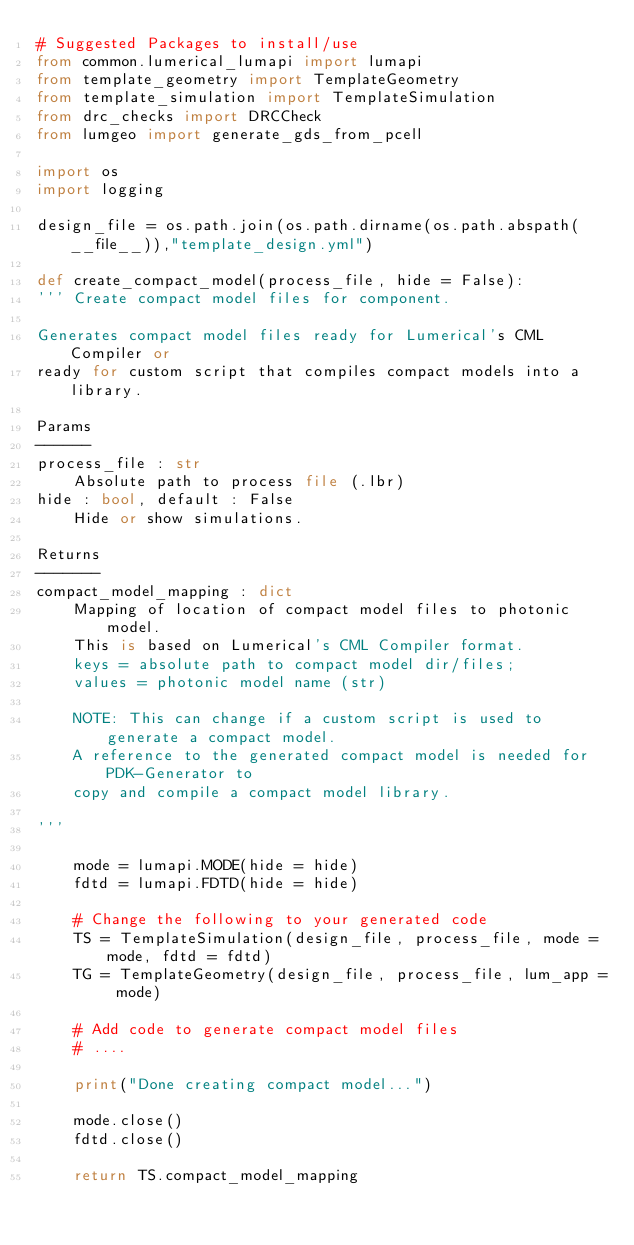Convert code to text. <code><loc_0><loc_0><loc_500><loc_500><_Python_># Suggested Packages to install/use
from common.lumerical_lumapi import lumapi
from template_geometry import TemplateGeometry
from template_simulation import TemplateSimulation
from drc_checks import DRCCheck
from lumgeo import generate_gds_from_pcell

import os
import logging

design_file = os.path.join(os.path.dirname(os.path.abspath(__file__)),"template_design.yml")

def create_compact_model(process_file, hide = False):
''' Create compact model files for component.

Generates compact model files ready for Lumerical's CML Compiler or 
ready for custom script that compiles compact models into a library.

Params
------
process_file : str
    Absolute path to process file (.lbr)
hide : bool, default : False
    Hide or show simulations.
    
Returns
-------
compact_model_mapping : dict
    Mapping of location of compact model files to photonic model.
    This is based on Lumerical's CML Compiler format.
    keys = absolute path to compact model dir/files;
    values = photonic model name (str)
    
    NOTE: This can change if a custom script is used to generate a compact model.
    A reference to the generated compact model is needed for PDK-Generator to 
    copy and compile a compact model library.
    
'''

    mode = lumapi.MODE(hide = hide)
    fdtd = lumapi.FDTD(hide = hide)
    
    # Change the following to your generated code
    TS = TemplateSimulation(design_file, process_file, mode = mode, fdtd = fdtd)
    TG = TemplateGeometry(design_file, process_file, lum_app = mode)
    
    # Add code to generate compact model files
    # ....
    
    print("Done creating compact model...")
    
    mode.close()
    fdtd.close()
    
    return TS.compact_model_mapping
    </code> 